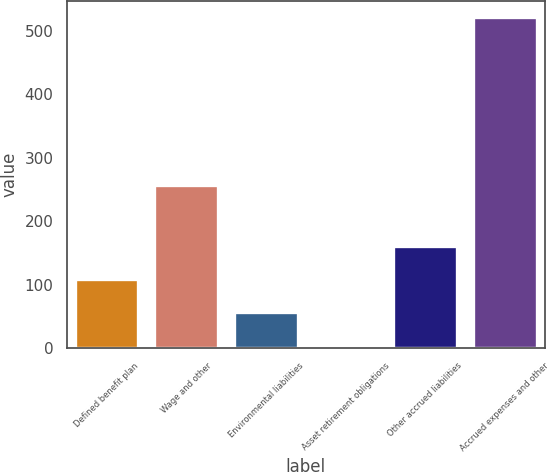<chart> <loc_0><loc_0><loc_500><loc_500><bar_chart><fcel>Defined benefit plan<fcel>Wage and other<fcel>Environmental liabilities<fcel>Asset retirement obligations<fcel>Other accrued liabilities<fcel>Accrued expenses and other<nl><fcel>108.4<fcel>257<fcel>56.7<fcel>5<fcel>160.1<fcel>522<nl></chart> 